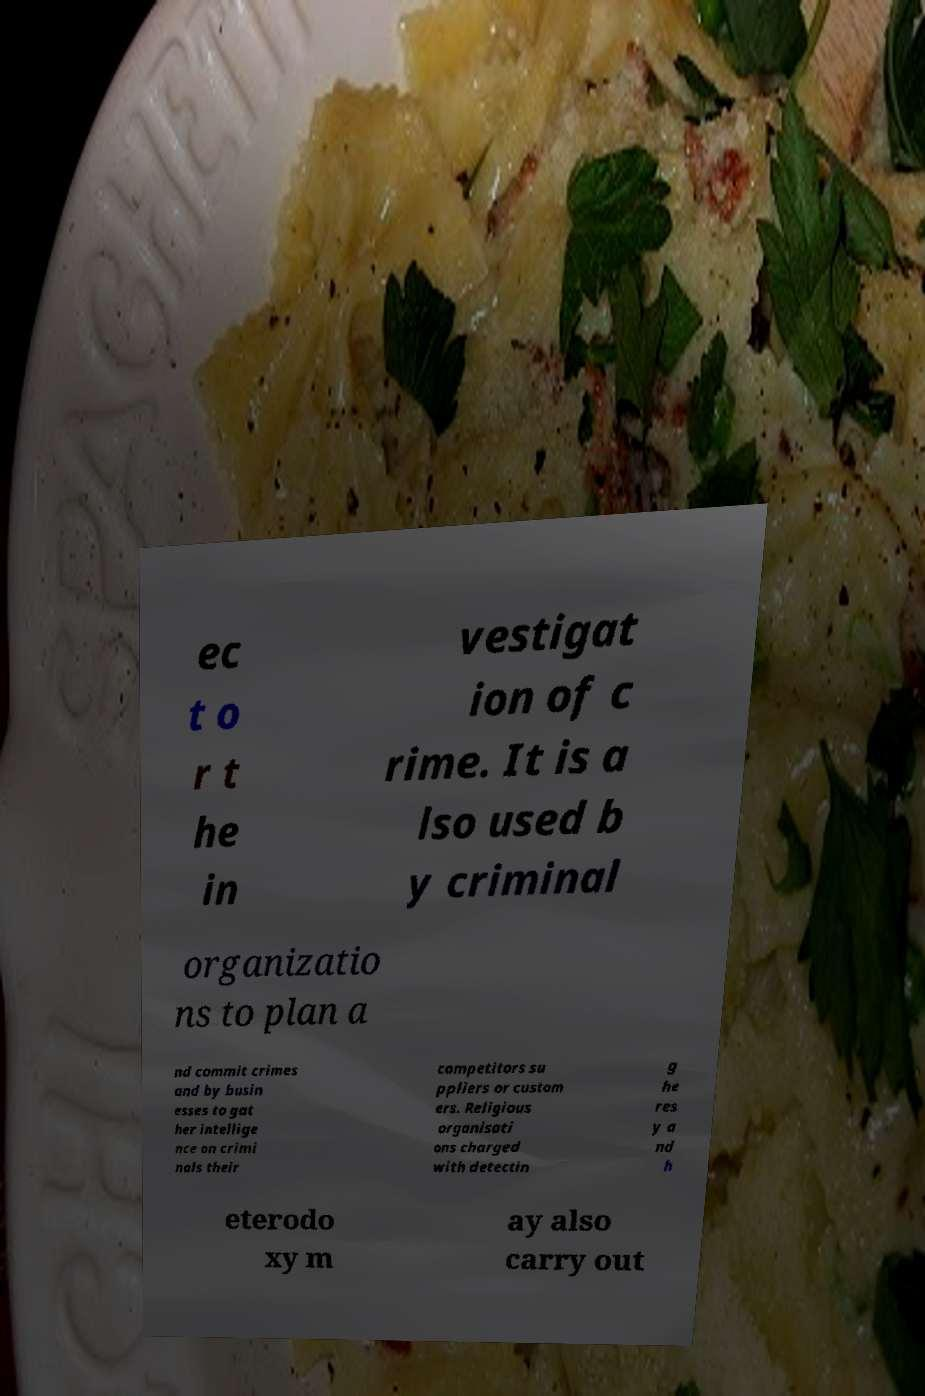For documentation purposes, I need the text within this image transcribed. Could you provide that? ec t o r t he in vestigat ion of c rime. It is a lso used b y criminal organizatio ns to plan a nd commit crimes and by busin esses to gat her intellige nce on crimi nals their competitors su ppliers or custom ers. Religious organisati ons charged with detectin g he res y a nd h eterodo xy m ay also carry out 